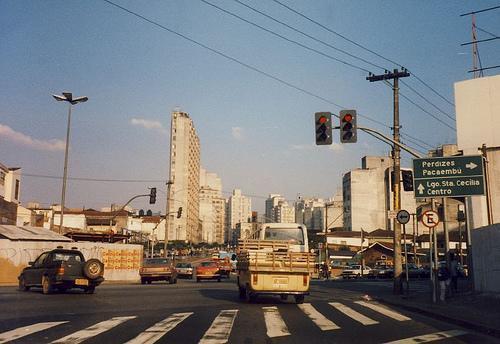How many white lines are there?
Give a very brief answer. 9. How many trucks are visible?
Give a very brief answer. 2. 